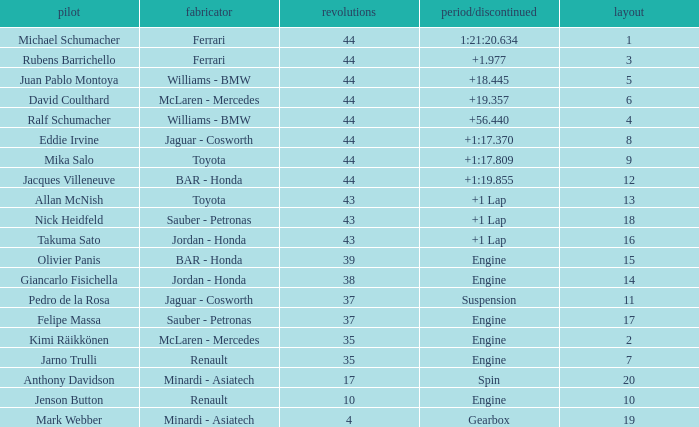What was the time of the driver on grid 3? 1.977. Could you parse the entire table as a dict? {'header': ['pilot', 'fabricator', 'revolutions', 'period/discontinued', 'layout'], 'rows': [['Michael Schumacher', 'Ferrari', '44', '1:21:20.634', '1'], ['Rubens Barrichello', 'Ferrari', '44', '+1.977', '3'], ['Juan Pablo Montoya', 'Williams - BMW', '44', '+18.445', '5'], ['David Coulthard', 'McLaren - Mercedes', '44', '+19.357', '6'], ['Ralf Schumacher', 'Williams - BMW', '44', '+56.440', '4'], ['Eddie Irvine', 'Jaguar - Cosworth', '44', '+1:17.370', '8'], ['Mika Salo', 'Toyota', '44', '+1:17.809', '9'], ['Jacques Villeneuve', 'BAR - Honda', '44', '+1:19.855', '12'], ['Allan McNish', 'Toyota', '43', '+1 Lap', '13'], ['Nick Heidfeld', 'Sauber - Petronas', '43', '+1 Lap', '18'], ['Takuma Sato', 'Jordan - Honda', '43', '+1 Lap', '16'], ['Olivier Panis', 'BAR - Honda', '39', 'Engine', '15'], ['Giancarlo Fisichella', 'Jordan - Honda', '38', 'Engine', '14'], ['Pedro de la Rosa', 'Jaguar - Cosworth', '37', 'Suspension', '11'], ['Felipe Massa', 'Sauber - Petronas', '37', 'Engine', '17'], ['Kimi Räikkönen', 'McLaren - Mercedes', '35', 'Engine', '2'], ['Jarno Trulli', 'Renault', '35', 'Engine', '7'], ['Anthony Davidson', 'Minardi - Asiatech', '17', 'Spin', '20'], ['Jenson Button', 'Renault', '10', 'Engine', '10'], ['Mark Webber', 'Minardi - Asiatech', '4', 'Gearbox', '19']]} 